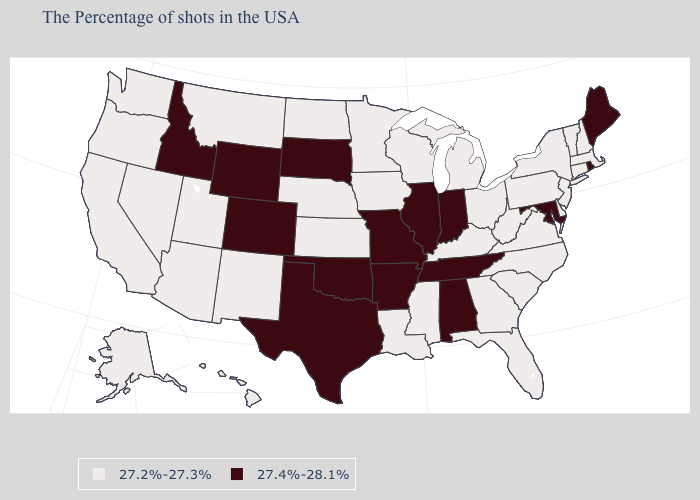Which states have the lowest value in the Northeast?
Answer briefly. Massachusetts, New Hampshire, Vermont, Connecticut, New York, New Jersey, Pennsylvania. Name the states that have a value in the range 27.2%-27.3%?
Quick response, please. Massachusetts, New Hampshire, Vermont, Connecticut, New York, New Jersey, Delaware, Pennsylvania, Virginia, North Carolina, South Carolina, West Virginia, Ohio, Florida, Georgia, Michigan, Kentucky, Wisconsin, Mississippi, Louisiana, Minnesota, Iowa, Kansas, Nebraska, North Dakota, New Mexico, Utah, Montana, Arizona, Nevada, California, Washington, Oregon, Alaska, Hawaii. Name the states that have a value in the range 27.2%-27.3%?
Answer briefly. Massachusetts, New Hampshire, Vermont, Connecticut, New York, New Jersey, Delaware, Pennsylvania, Virginia, North Carolina, South Carolina, West Virginia, Ohio, Florida, Georgia, Michigan, Kentucky, Wisconsin, Mississippi, Louisiana, Minnesota, Iowa, Kansas, Nebraska, North Dakota, New Mexico, Utah, Montana, Arizona, Nevada, California, Washington, Oregon, Alaska, Hawaii. Does the first symbol in the legend represent the smallest category?
Be succinct. Yes. Name the states that have a value in the range 27.2%-27.3%?
Short answer required. Massachusetts, New Hampshire, Vermont, Connecticut, New York, New Jersey, Delaware, Pennsylvania, Virginia, North Carolina, South Carolina, West Virginia, Ohio, Florida, Georgia, Michigan, Kentucky, Wisconsin, Mississippi, Louisiana, Minnesota, Iowa, Kansas, Nebraska, North Dakota, New Mexico, Utah, Montana, Arizona, Nevada, California, Washington, Oregon, Alaska, Hawaii. Among the states that border North Carolina , does Tennessee have the highest value?
Short answer required. Yes. Among the states that border Virginia , does Tennessee have the lowest value?
Short answer required. No. Name the states that have a value in the range 27.4%-28.1%?
Quick response, please. Maine, Rhode Island, Maryland, Indiana, Alabama, Tennessee, Illinois, Missouri, Arkansas, Oklahoma, Texas, South Dakota, Wyoming, Colorado, Idaho. Among the states that border Massachusetts , which have the highest value?
Short answer required. Rhode Island. Does Ohio have a lower value than Illinois?
Write a very short answer. Yes. What is the value of Georgia?
Give a very brief answer. 27.2%-27.3%. What is the value of Idaho?
Be succinct. 27.4%-28.1%. What is the value of Washington?
Write a very short answer. 27.2%-27.3%. Name the states that have a value in the range 27.2%-27.3%?
Quick response, please. Massachusetts, New Hampshire, Vermont, Connecticut, New York, New Jersey, Delaware, Pennsylvania, Virginia, North Carolina, South Carolina, West Virginia, Ohio, Florida, Georgia, Michigan, Kentucky, Wisconsin, Mississippi, Louisiana, Minnesota, Iowa, Kansas, Nebraska, North Dakota, New Mexico, Utah, Montana, Arizona, Nevada, California, Washington, Oregon, Alaska, Hawaii. Name the states that have a value in the range 27.4%-28.1%?
Concise answer only. Maine, Rhode Island, Maryland, Indiana, Alabama, Tennessee, Illinois, Missouri, Arkansas, Oklahoma, Texas, South Dakota, Wyoming, Colorado, Idaho. 